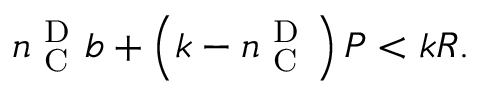Convert formula to latex. <formula><loc_0><loc_0><loc_500><loc_500>n _ { C } ^ { D } b + \left ( k - n _ { C } ^ { D } \right ) P < k R .</formula> 